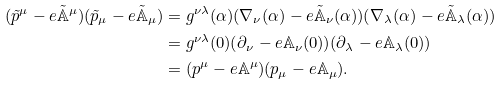<formula> <loc_0><loc_0><loc_500><loc_500>( { \tilde { p } } ^ { \mu } - e { \tilde { { \mathbb { A } } } } ^ { \mu } ) ( { \tilde { p } } _ { \mu } - e { \tilde { { \mathbb { A } } } } _ { \mu } ) & = g ^ { \nu \lambda } ( { \alpha } ) ( { \nabla } _ { \nu } ( { \alpha } ) - e { \tilde { { \mathbb { A } } } } _ { \nu } ( \alpha ) ) ( { \nabla } _ { \lambda } ( { \alpha } ) - e { \tilde { { \mathbb { A } } } } _ { \lambda } ( \alpha ) ) \\ & = g ^ { \nu \lambda } ( 0 ) ( { \partial } _ { \nu } - e { \mathbb { A } } _ { \nu } ( 0 ) ) ( { \partial } _ { \lambda } - e { \mathbb { A } } _ { \lambda } ( 0 ) ) \\ & = ( p ^ { \mu } - e { \mathbb { A } } ^ { \mu } ) ( p _ { \mu } - e { \mathbb { A } } _ { \mu } ) .</formula> 